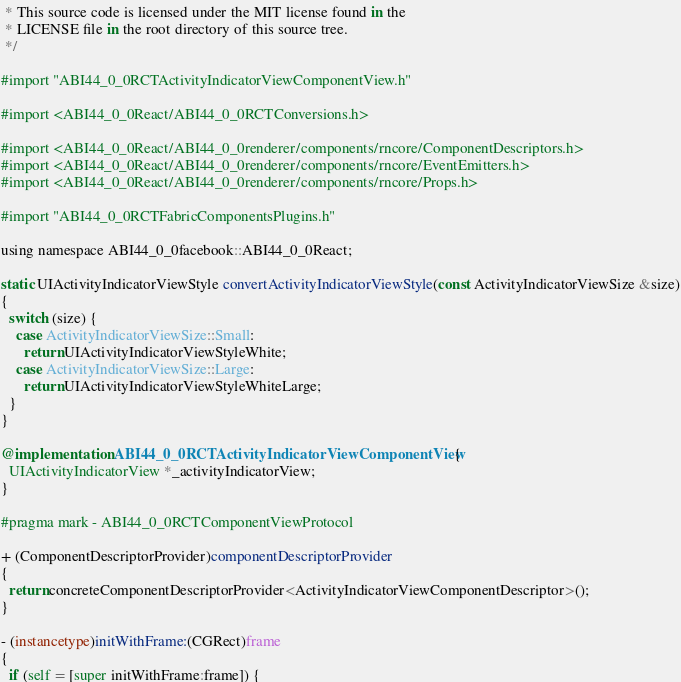Convert code to text. <code><loc_0><loc_0><loc_500><loc_500><_ObjectiveC_> * This source code is licensed under the MIT license found in the
 * LICENSE file in the root directory of this source tree.
 */

#import "ABI44_0_0RCTActivityIndicatorViewComponentView.h"

#import <ABI44_0_0React/ABI44_0_0RCTConversions.h>

#import <ABI44_0_0React/ABI44_0_0renderer/components/rncore/ComponentDescriptors.h>
#import <ABI44_0_0React/ABI44_0_0renderer/components/rncore/EventEmitters.h>
#import <ABI44_0_0React/ABI44_0_0renderer/components/rncore/Props.h>

#import "ABI44_0_0RCTFabricComponentsPlugins.h"

using namespace ABI44_0_0facebook::ABI44_0_0React;

static UIActivityIndicatorViewStyle convertActivityIndicatorViewStyle(const ActivityIndicatorViewSize &size)
{
  switch (size) {
    case ActivityIndicatorViewSize::Small:
      return UIActivityIndicatorViewStyleWhite;
    case ActivityIndicatorViewSize::Large:
      return UIActivityIndicatorViewStyleWhiteLarge;
  }
}

@implementation ABI44_0_0RCTActivityIndicatorViewComponentView {
  UIActivityIndicatorView *_activityIndicatorView;
}

#pragma mark - ABI44_0_0RCTComponentViewProtocol

+ (ComponentDescriptorProvider)componentDescriptorProvider
{
  return concreteComponentDescriptorProvider<ActivityIndicatorViewComponentDescriptor>();
}

- (instancetype)initWithFrame:(CGRect)frame
{
  if (self = [super initWithFrame:frame]) {</code> 